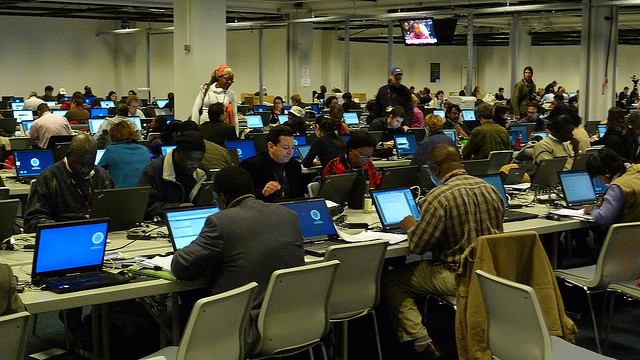Can you describe the atmosphere of this place? The room is filled with a sense of focused activity as many attendees are engaged with their computers, possibly indicating a work-oriented event. The high concentration of people and technology suggests a collaborative and intellectual environment. 